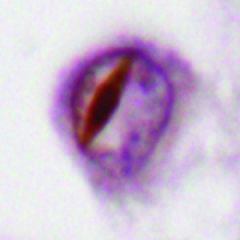re some forms of ftld associated with neuronal intranuclear inclusions containing tdp43?
Answer the question using a single word or phrase. Yes 